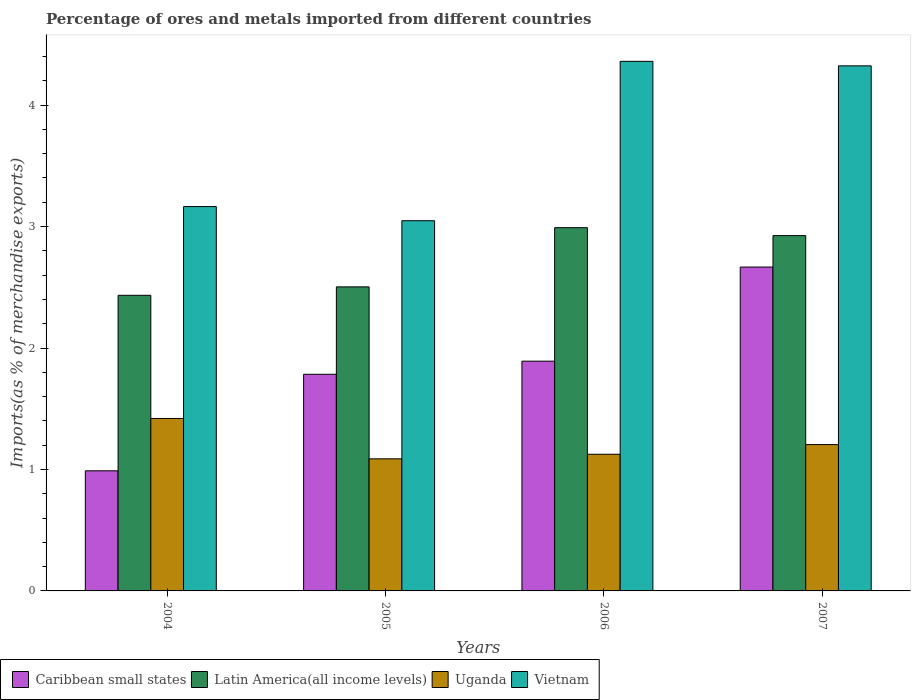How many different coloured bars are there?
Make the answer very short. 4. How many groups of bars are there?
Your response must be concise. 4. Are the number of bars on each tick of the X-axis equal?
Your response must be concise. Yes. What is the label of the 2nd group of bars from the left?
Ensure brevity in your answer.  2005. In how many cases, is the number of bars for a given year not equal to the number of legend labels?
Your response must be concise. 0. What is the percentage of imports to different countries in Uganda in 2006?
Ensure brevity in your answer.  1.13. Across all years, what is the maximum percentage of imports to different countries in Latin America(all income levels)?
Offer a terse response. 2.99. Across all years, what is the minimum percentage of imports to different countries in Vietnam?
Ensure brevity in your answer.  3.05. In which year was the percentage of imports to different countries in Latin America(all income levels) maximum?
Ensure brevity in your answer.  2006. In which year was the percentage of imports to different countries in Vietnam minimum?
Provide a succinct answer. 2005. What is the total percentage of imports to different countries in Vietnam in the graph?
Provide a short and direct response. 14.9. What is the difference between the percentage of imports to different countries in Vietnam in 2004 and that in 2006?
Make the answer very short. -1.2. What is the difference between the percentage of imports to different countries in Latin America(all income levels) in 2005 and the percentage of imports to different countries in Vietnam in 2006?
Offer a terse response. -1.86. What is the average percentage of imports to different countries in Uganda per year?
Your answer should be very brief. 1.21. In the year 2004, what is the difference between the percentage of imports to different countries in Caribbean small states and percentage of imports to different countries in Latin America(all income levels)?
Give a very brief answer. -1.44. What is the ratio of the percentage of imports to different countries in Vietnam in 2004 to that in 2006?
Ensure brevity in your answer.  0.73. Is the percentage of imports to different countries in Uganda in 2006 less than that in 2007?
Your answer should be very brief. Yes. What is the difference between the highest and the second highest percentage of imports to different countries in Latin America(all income levels)?
Offer a terse response. 0.07. What is the difference between the highest and the lowest percentage of imports to different countries in Uganda?
Provide a short and direct response. 0.33. In how many years, is the percentage of imports to different countries in Uganda greater than the average percentage of imports to different countries in Uganda taken over all years?
Ensure brevity in your answer.  1. Is the sum of the percentage of imports to different countries in Caribbean small states in 2004 and 2005 greater than the maximum percentage of imports to different countries in Uganda across all years?
Give a very brief answer. Yes. Is it the case that in every year, the sum of the percentage of imports to different countries in Caribbean small states and percentage of imports to different countries in Vietnam is greater than the sum of percentage of imports to different countries in Uganda and percentage of imports to different countries in Latin America(all income levels)?
Your answer should be very brief. No. What does the 4th bar from the left in 2005 represents?
Offer a very short reply. Vietnam. What does the 3rd bar from the right in 2007 represents?
Provide a succinct answer. Latin America(all income levels). How many bars are there?
Make the answer very short. 16. Are all the bars in the graph horizontal?
Ensure brevity in your answer.  No. What is the difference between two consecutive major ticks on the Y-axis?
Your response must be concise. 1. How are the legend labels stacked?
Ensure brevity in your answer.  Horizontal. What is the title of the graph?
Make the answer very short. Percentage of ores and metals imported from different countries. Does "Mauritius" appear as one of the legend labels in the graph?
Make the answer very short. No. What is the label or title of the Y-axis?
Your answer should be very brief. Imports(as % of merchandise exports). What is the Imports(as % of merchandise exports) in Caribbean small states in 2004?
Provide a short and direct response. 0.99. What is the Imports(as % of merchandise exports) of Latin America(all income levels) in 2004?
Offer a very short reply. 2.43. What is the Imports(as % of merchandise exports) of Uganda in 2004?
Your answer should be very brief. 1.42. What is the Imports(as % of merchandise exports) of Vietnam in 2004?
Give a very brief answer. 3.16. What is the Imports(as % of merchandise exports) of Caribbean small states in 2005?
Provide a short and direct response. 1.78. What is the Imports(as % of merchandise exports) in Latin America(all income levels) in 2005?
Provide a succinct answer. 2.5. What is the Imports(as % of merchandise exports) of Uganda in 2005?
Give a very brief answer. 1.09. What is the Imports(as % of merchandise exports) of Vietnam in 2005?
Your response must be concise. 3.05. What is the Imports(as % of merchandise exports) of Caribbean small states in 2006?
Your answer should be compact. 1.89. What is the Imports(as % of merchandise exports) in Latin America(all income levels) in 2006?
Keep it short and to the point. 2.99. What is the Imports(as % of merchandise exports) of Uganda in 2006?
Ensure brevity in your answer.  1.13. What is the Imports(as % of merchandise exports) in Vietnam in 2006?
Offer a very short reply. 4.36. What is the Imports(as % of merchandise exports) of Caribbean small states in 2007?
Make the answer very short. 2.67. What is the Imports(as % of merchandise exports) in Latin America(all income levels) in 2007?
Offer a terse response. 2.93. What is the Imports(as % of merchandise exports) of Uganda in 2007?
Offer a very short reply. 1.2. What is the Imports(as % of merchandise exports) in Vietnam in 2007?
Keep it short and to the point. 4.32. Across all years, what is the maximum Imports(as % of merchandise exports) in Caribbean small states?
Provide a short and direct response. 2.67. Across all years, what is the maximum Imports(as % of merchandise exports) in Latin America(all income levels)?
Your response must be concise. 2.99. Across all years, what is the maximum Imports(as % of merchandise exports) of Uganda?
Your response must be concise. 1.42. Across all years, what is the maximum Imports(as % of merchandise exports) in Vietnam?
Your response must be concise. 4.36. Across all years, what is the minimum Imports(as % of merchandise exports) of Caribbean small states?
Make the answer very short. 0.99. Across all years, what is the minimum Imports(as % of merchandise exports) of Latin America(all income levels)?
Your answer should be compact. 2.43. Across all years, what is the minimum Imports(as % of merchandise exports) of Uganda?
Make the answer very short. 1.09. Across all years, what is the minimum Imports(as % of merchandise exports) of Vietnam?
Offer a terse response. 3.05. What is the total Imports(as % of merchandise exports) in Caribbean small states in the graph?
Your answer should be very brief. 7.33. What is the total Imports(as % of merchandise exports) of Latin America(all income levels) in the graph?
Your answer should be compact. 10.85. What is the total Imports(as % of merchandise exports) in Uganda in the graph?
Your answer should be compact. 4.84. What is the total Imports(as % of merchandise exports) of Vietnam in the graph?
Provide a succinct answer. 14.9. What is the difference between the Imports(as % of merchandise exports) in Caribbean small states in 2004 and that in 2005?
Offer a terse response. -0.79. What is the difference between the Imports(as % of merchandise exports) in Latin America(all income levels) in 2004 and that in 2005?
Your answer should be very brief. -0.07. What is the difference between the Imports(as % of merchandise exports) in Uganda in 2004 and that in 2005?
Provide a succinct answer. 0.33. What is the difference between the Imports(as % of merchandise exports) in Vietnam in 2004 and that in 2005?
Give a very brief answer. 0.12. What is the difference between the Imports(as % of merchandise exports) of Caribbean small states in 2004 and that in 2006?
Provide a succinct answer. -0.9. What is the difference between the Imports(as % of merchandise exports) in Latin America(all income levels) in 2004 and that in 2006?
Make the answer very short. -0.56. What is the difference between the Imports(as % of merchandise exports) of Uganda in 2004 and that in 2006?
Provide a short and direct response. 0.29. What is the difference between the Imports(as % of merchandise exports) in Vietnam in 2004 and that in 2006?
Make the answer very short. -1.2. What is the difference between the Imports(as % of merchandise exports) of Caribbean small states in 2004 and that in 2007?
Give a very brief answer. -1.68. What is the difference between the Imports(as % of merchandise exports) in Latin America(all income levels) in 2004 and that in 2007?
Provide a short and direct response. -0.49. What is the difference between the Imports(as % of merchandise exports) of Uganda in 2004 and that in 2007?
Give a very brief answer. 0.21. What is the difference between the Imports(as % of merchandise exports) of Vietnam in 2004 and that in 2007?
Keep it short and to the point. -1.16. What is the difference between the Imports(as % of merchandise exports) in Caribbean small states in 2005 and that in 2006?
Keep it short and to the point. -0.11. What is the difference between the Imports(as % of merchandise exports) of Latin America(all income levels) in 2005 and that in 2006?
Make the answer very short. -0.49. What is the difference between the Imports(as % of merchandise exports) of Uganda in 2005 and that in 2006?
Offer a very short reply. -0.04. What is the difference between the Imports(as % of merchandise exports) in Vietnam in 2005 and that in 2006?
Provide a short and direct response. -1.31. What is the difference between the Imports(as % of merchandise exports) in Caribbean small states in 2005 and that in 2007?
Your answer should be compact. -0.88. What is the difference between the Imports(as % of merchandise exports) of Latin America(all income levels) in 2005 and that in 2007?
Make the answer very short. -0.42. What is the difference between the Imports(as % of merchandise exports) in Uganda in 2005 and that in 2007?
Provide a succinct answer. -0.12. What is the difference between the Imports(as % of merchandise exports) of Vietnam in 2005 and that in 2007?
Keep it short and to the point. -1.28. What is the difference between the Imports(as % of merchandise exports) of Caribbean small states in 2006 and that in 2007?
Make the answer very short. -0.77. What is the difference between the Imports(as % of merchandise exports) in Latin America(all income levels) in 2006 and that in 2007?
Provide a short and direct response. 0.07. What is the difference between the Imports(as % of merchandise exports) of Uganda in 2006 and that in 2007?
Your answer should be compact. -0.08. What is the difference between the Imports(as % of merchandise exports) in Vietnam in 2006 and that in 2007?
Your answer should be very brief. 0.04. What is the difference between the Imports(as % of merchandise exports) in Caribbean small states in 2004 and the Imports(as % of merchandise exports) in Latin America(all income levels) in 2005?
Your answer should be compact. -1.51. What is the difference between the Imports(as % of merchandise exports) in Caribbean small states in 2004 and the Imports(as % of merchandise exports) in Uganda in 2005?
Ensure brevity in your answer.  -0.1. What is the difference between the Imports(as % of merchandise exports) in Caribbean small states in 2004 and the Imports(as % of merchandise exports) in Vietnam in 2005?
Your answer should be very brief. -2.06. What is the difference between the Imports(as % of merchandise exports) in Latin America(all income levels) in 2004 and the Imports(as % of merchandise exports) in Uganda in 2005?
Give a very brief answer. 1.35. What is the difference between the Imports(as % of merchandise exports) in Latin America(all income levels) in 2004 and the Imports(as % of merchandise exports) in Vietnam in 2005?
Offer a very short reply. -0.61. What is the difference between the Imports(as % of merchandise exports) of Uganda in 2004 and the Imports(as % of merchandise exports) of Vietnam in 2005?
Give a very brief answer. -1.63. What is the difference between the Imports(as % of merchandise exports) of Caribbean small states in 2004 and the Imports(as % of merchandise exports) of Latin America(all income levels) in 2006?
Give a very brief answer. -2. What is the difference between the Imports(as % of merchandise exports) of Caribbean small states in 2004 and the Imports(as % of merchandise exports) of Uganda in 2006?
Provide a succinct answer. -0.14. What is the difference between the Imports(as % of merchandise exports) in Caribbean small states in 2004 and the Imports(as % of merchandise exports) in Vietnam in 2006?
Ensure brevity in your answer.  -3.37. What is the difference between the Imports(as % of merchandise exports) of Latin America(all income levels) in 2004 and the Imports(as % of merchandise exports) of Uganda in 2006?
Provide a succinct answer. 1.31. What is the difference between the Imports(as % of merchandise exports) in Latin America(all income levels) in 2004 and the Imports(as % of merchandise exports) in Vietnam in 2006?
Your answer should be very brief. -1.93. What is the difference between the Imports(as % of merchandise exports) in Uganda in 2004 and the Imports(as % of merchandise exports) in Vietnam in 2006?
Make the answer very short. -2.94. What is the difference between the Imports(as % of merchandise exports) in Caribbean small states in 2004 and the Imports(as % of merchandise exports) in Latin America(all income levels) in 2007?
Make the answer very short. -1.94. What is the difference between the Imports(as % of merchandise exports) of Caribbean small states in 2004 and the Imports(as % of merchandise exports) of Uganda in 2007?
Your answer should be compact. -0.22. What is the difference between the Imports(as % of merchandise exports) of Caribbean small states in 2004 and the Imports(as % of merchandise exports) of Vietnam in 2007?
Your response must be concise. -3.33. What is the difference between the Imports(as % of merchandise exports) in Latin America(all income levels) in 2004 and the Imports(as % of merchandise exports) in Uganda in 2007?
Provide a succinct answer. 1.23. What is the difference between the Imports(as % of merchandise exports) of Latin America(all income levels) in 2004 and the Imports(as % of merchandise exports) of Vietnam in 2007?
Your answer should be compact. -1.89. What is the difference between the Imports(as % of merchandise exports) in Uganda in 2004 and the Imports(as % of merchandise exports) in Vietnam in 2007?
Offer a terse response. -2.9. What is the difference between the Imports(as % of merchandise exports) in Caribbean small states in 2005 and the Imports(as % of merchandise exports) in Latin America(all income levels) in 2006?
Your response must be concise. -1.21. What is the difference between the Imports(as % of merchandise exports) of Caribbean small states in 2005 and the Imports(as % of merchandise exports) of Uganda in 2006?
Your response must be concise. 0.66. What is the difference between the Imports(as % of merchandise exports) of Caribbean small states in 2005 and the Imports(as % of merchandise exports) of Vietnam in 2006?
Offer a terse response. -2.58. What is the difference between the Imports(as % of merchandise exports) of Latin America(all income levels) in 2005 and the Imports(as % of merchandise exports) of Uganda in 2006?
Ensure brevity in your answer.  1.38. What is the difference between the Imports(as % of merchandise exports) in Latin America(all income levels) in 2005 and the Imports(as % of merchandise exports) in Vietnam in 2006?
Your answer should be very brief. -1.86. What is the difference between the Imports(as % of merchandise exports) of Uganda in 2005 and the Imports(as % of merchandise exports) of Vietnam in 2006?
Offer a very short reply. -3.27. What is the difference between the Imports(as % of merchandise exports) in Caribbean small states in 2005 and the Imports(as % of merchandise exports) in Latin America(all income levels) in 2007?
Ensure brevity in your answer.  -1.14. What is the difference between the Imports(as % of merchandise exports) of Caribbean small states in 2005 and the Imports(as % of merchandise exports) of Uganda in 2007?
Ensure brevity in your answer.  0.58. What is the difference between the Imports(as % of merchandise exports) in Caribbean small states in 2005 and the Imports(as % of merchandise exports) in Vietnam in 2007?
Make the answer very short. -2.54. What is the difference between the Imports(as % of merchandise exports) of Latin America(all income levels) in 2005 and the Imports(as % of merchandise exports) of Uganda in 2007?
Your answer should be very brief. 1.3. What is the difference between the Imports(as % of merchandise exports) in Latin America(all income levels) in 2005 and the Imports(as % of merchandise exports) in Vietnam in 2007?
Offer a very short reply. -1.82. What is the difference between the Imports(as % of merchandise exports) of Uganda in 2005 and the Imports(as % of merchandise exports) of Vietnam in 2007?
Make the answer very short. -3.24. What is the difference between the Imports(as % of merchandise exports) in Caribbean small states in 2006 and the Imports(as % of merchandise exports) in Latin America(all income levels) in 2007?
Your answer should be very brief. -1.03. What is the difference between the Imports(as % of merchandise exports) of Caribbean small states in 2006 and the Imports(as % of merchandise exports) of Uganda in 2007?
Ensure brevity in your answer.  0.69. What is the difference between the Imports(as % of merchandise exports) in Caribbean small states in 2006 and the Imports(as % of merchandise exports) in Vietnam in 2007?
Provide a short and direct response. -2.43. What is the difference between the Imports(as % of merchandise exports) in Latin America(all income levels) in 2006 and the Imports(as % of merchandise exports) in Uganda in 2007?
Provide a succinct answer. 1.79. What is the difference between the Imports(as % of merchandise exports) in Latin America(all income levels) in 2006 and the Imports(as % of merchandise exports) in Vietnam in 2007?
Offer a very short reply. -1.33. What is the difference between the Imports(as % of merchandise exports) of Uganda in 2006 and the Imports(as % of merchandise exports) of Vietnam in 2007?
Your response must be concise. -3.2. What is the average Imports(as % of merchandise exports) of Caribbean small states per year?
Ensure brevity in your answer.  1.83. What is the average Imports(as % of merchandise exports) in Latin America(all income levels) per year?
Your answer should be very brief. 2.71. What is the average Imports(as % of merchandise exports) of Uganda per year?
Keep it short and to the point. 1.21. What is the average Imports(as % of merchandise exports) of Vietnam per year?
Your answer should be very brief. 3.72. In the year 2004, what is the difference between the Imports(as % of merchandise exports) in Caribbean small states and Imports(as % of merchandise exports) in Latin America(all income levels)?
Give a very brief answer. -1.44. In the year 2004, what is the difference between the Imports(as % of merchandise exports) of Caribbean small states and Imports(as % of merchandise exports) of Uganda?
Keep it short and to the point. -0.43. In the year 2004, what is the difference between the Imports(as % of merchandise exports) of Caribbean small states and Imports(as % of merchandise exports) of Vietnam?
Ensure brevity in your answer.  -2.18. In the year 2004, what is the difference between the Imports(as % of merchandise exports) of Latin America(all income levels) and Imports(as % of merchandise exports) of Uganda?
Make the answer very short. 1.01. In the year 2004, what is the difference between the Imports(as % of merchandise exports) in Latin America(all income levels) and Imports(as % of merchandise exports) in Vietnam?
Your response must be concise. -0.73. In the year 2004, what is the difference between the Imports(as % of merchandise exports) of Uganda and Imports(as % of merchandise exports) of Vietnam?
Your answer should be very brief. -1.74. In the year 2005, what is the difference between the Imports(as % of merchandise exports) of Caribbean small states and Imports(as % of merchandise exports) of Latin America(all income levels)?
Make the answer very short. -0.72. In the year 2005, what is the difference between the Imports(as % of merchandise exports) of Caribbean small states and Imports(as % of merchandise exports) of Uganda?
Keep it short and to the point. 0.7. In the year 2005, what is the difference between the Imports(as % of merchandise exports) of Caribbean small states and Imports(as % of merchandise exports) of Vietnam?
Your response must be concise. -1.26. In the year 2005, what is the difference between the Imports(as % of merchandise exports) in Latin America(all income levels) and Imports(as % of merchandise exports) in Uganda?
Provide a succinct answer. 1.42. In the year 2005, what is the difference between the Imports(as % of merchandise exports) in Latin America(all income levels) and Imports(as % of merchandise exports) in Vietnam?
Ensure brevity in your answer.  -0.54. In the year 2005, what is the difference between the Imports(as % of merchandise exports) in Uganda and Imports(as % of merchandise exports) in Vietnam?
Your answer should be very brief. -1.96. In the year 2006, what is the difference between the Imports(as % of merchandise exports) of Caribbean small states and Imports(as % of merchandise exports) of Latin America(all income levels)?
Your response must be concise. -1.1. In the year 2006, what is the difference between the Imports(as % of merchandise exports) of Caribbean small states and Imports(as % of merchandise exports) of Uganda?
Your answer should be compact. 0.77. In the year 2006, what is the difference between the Imports(as % of merchandise exports) of Caribbean small states and Imports(as % of merchandise exports) of Vietnam?
Make the answer very short. -2.47. In the year 2006, what is the difference between the Imports(as % of merchandise exports) of Latin America(all income levels) and Imports(as % of merchandise exports) of Uganda?
Your response must be concise. 1.87. In the year 2006, what is the difference between the Imports(as % of merchandise exports) in Latin America(all income levels) and Imports(as % of merchandise exports) in Vietnam?
Offer a very short reply. -1.37. In the year 2006, what is the difference between the Imports(as % of merchandise exports) of Uganda and Imports(as % of merchandise exports) of Vietnam?
Ensure brevity in your answer.  -3.23. In the year 2007, what is the difference between the Imports(as % of merchandise exports) of Caribbean small states and Imports(as % of merchandise exports) of Latin America(all income levels)?
Ensure brevity in your answer.  -0.26. In the year 2007, what is the difference between the Imports(as % of merchandise exports) in Caribbean small states and Imports(as % of merchandise exports) in Uganda?
Offer a very short reply. 1.46. In the year 2007, what is the difference between the Imports(as % of merchandise exports) of Caribbean small states and Imports(as % of merchandise exports) of Vietnam?
Make the answer very short. -1.66. In the year 2007, what is the difference between the Imports(as % of merchandise exports) in Latin America(all income levels) and Imports(as % of merchandise exports) in Uganda?
Your answer should be compact. 1.72. In the year 2007, what is the difference between the Imports(as % of merchandise exports) in Latin America(all income levels) and Imports(as % of merchandise exports) in Vietnam?
Keep it short and to the point. -1.4. In the year 2007, what is the difference between the Imports(as % of merchandise exports) in Uganda and Imports(as % of merchandise exports) in Vietnam?
Offer a very short reply. -3.12. What is the ratio of the Imports(as % of merchandise exports) of Caribbean small states in 2004 to that in 2005?
Offer a terse response. 0.55. What is the ratio of the Imports(as % of merchandise exports) in Latin America(all income levels) in 2004 to that in 2005?
Offer a terse response. 0.97. What is the ratio of the Imports(as % of merchandise exports) of Uganda in 2004 to that in 2005?
Keep it short and to the point. 1.31. What is the ratio of the Imports(as % of merchandise exports) of Vietnam in 2004 to that in 2005?
Your answer should be compact. 1.04. What is the ratio of the Imports(as % of merchandise exports) in Caribbean small states in 2004 to that in 2006?
Give a very brief answer. 0.52. What is the ratio of the Imports(as % of merchandise exports) of Latin America(all income levels) in 2004 to that in 2006?
Ensure brevity in your answer.  0.81. What is the ratio of the Imports(as % of merchandise exports) in Uganda in 2004 to that in 2006?
Keep it short and to the point. 1.26. What is the ratio of the Imports(as % of merchandise exports) in Vietnam in 2004 to that in 2006?
Give a very brief answer. 0.73. What is the ratio of the Imports(as % of merchandise exports) in Caribbean small states in 2004 to that in 2007?
Keep it short and to the point. 0.37. What is the ratio of the Imports(as % of merchandise exports) in Latin America(all income levels) in 2004 to that in 2007?
Offer a terse response. 0.83. What is the ratio of the Imports(as % of merchandise exports) in Uganda in 2004 to that in 2007?
Provide a short and direct response. 1.18. What is the ratio of the Imports(as % of merchandise exports) of Vietnam in 2004 to that in 2007?
Ensure brevity in your answer.  0.73. What is the ratio of the Imports(as % of merchandise exports) of Caribbean small states in 2005 to that in 2006?
Offer a very short reply. 0.94. What is the ratio of the Imports(as % of merchandise exports) of Latin America(all income levels) in 2005 to that in 2006?
Your response must be concise. 0.84. What is the ratio of the Imports(as % of merchandise exports) in Uganda in 2005 to that in 2006?
Offer a very short reply. 0.97. What is the ratio of the Imports(as % of merchandise exports) in Vietnam in 2005 to that in 2006?
Provide a short and direct response. 0.7. What is the ratio of the Imports(as % of merchandise exports) of Caribbean small states in 2005 to that in 2007?
Offer a very short reply. 0.67. What is the ratio of the Imports(as % of merchandise exports) of Latin America(all income levels) in 2005 to that in 2007?
Your response must be concise. 0.86. What is the ratio of the Imports(as % of merchandise exports) in Uganda in 2005 to that in 2007?
Ensure brevity in your answer.  0.9. What is the ratio of the Imports(as % of merchandise exports) of Vietnam in 2005 to that in 2007?
Your answer should be compact. 0.7. What is the ratio of the Imports(as % of merchandise exports) in Caribbean small states in 2006 to that in 2007?
Your answer should be compact. 0.71. What is the ratio of the Imports(as % of merchandise exports) in Latin America(all income levels) in 2006 to that in 2007?
Make the answer very short. 1.02. What is the ratio of the Imports(as % of merchandise exports) in Uganda in 2006 to that in 2007?
Provide a short and direct response. 0.93. What is the ratio of the Imports(as % of merchandise exports) in Vietnam in 2006 to that in 2007?
Keep it short and to the point. 1.01. What is the difference between the highest and the second highest Imports(as % of merchandise exports) of Caribbean small states?
Make the answer very short. 0.77. What is the difference between the highest and the second highest Imports(as % of merchandise exports) in Latin America(all income levels)?
Offer a very short reply. 0.07. What is the difference between the highest and the second highest Imports(as % of merchandise exports) of Uganda?
Your answer should be very brief. 0.21. What is the difference between the highest and the second highest Imports(as % of merchandise exports) in Vietnam?
Provide a short and direct response. 0.04. What is the difference between the highest and the lowest Imports(as % of merchandise exports) of Caribbean small states?
Offer a terse response. 1.68. What is the difference between the highest and the lowest Imports(as % of merchandise exports) of Latin America(all income levels)?
Give a very brief answer. 0.56. What is the difference between the highest and the lowest Imports(as % of merchandise exports) in Uganda?
Ensure brevity in your answer.  0.33. What is the difference between the highest and the lowest Imports(as % of merchandise exports) in Vietnam?
Provide a succinct answer. 1.31. 